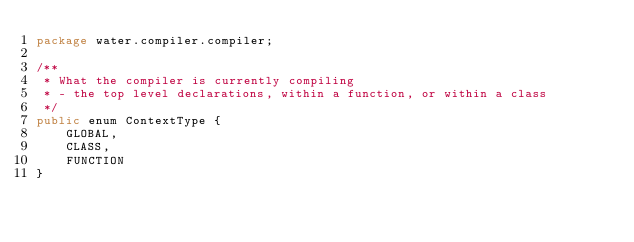<code> <loc_0><loc_0><loc_500><loc_500><_Java_>package water.compiler.compiler;

/**
 * What the compiler is currently compiling
 * - the top level declarations, within a function, or within a class
 */
public enum ContextType {
	GLOBAL,
	CLASS,
	FUNCTION
}
</code> 